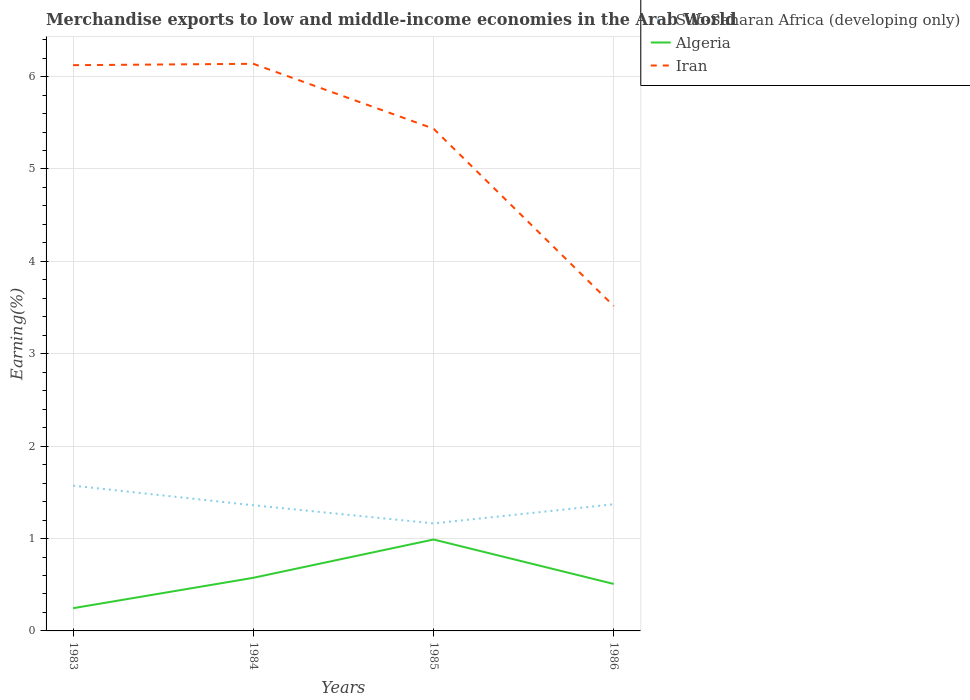Is the number of lines equal to the number of legend labels?
Ensure brevity in your answer.  Yes. Across all years, what is the maximum percentage of amount earned from merchandise exports in Sub-Saharan Africa (developing only)?
Keep it short and to the point. 1.16. What is the total percentage of amount earned from merchandise exports in Sub-Saharan Africa (developing only) in the graph?
Your answer should be very brief. 0.21. What is the difference between the highest and the second highest percentage of amount earned from merchandise exports in Algeria?
Give a very brief answer. 0.74. Is the percentage of amount earned from merchandise exports in Iran strictly greater than the percentage of amount earned from merchandise exports in Sub-Saharan Africa (developing only) over the years?
Your answer should be very brief. No. How many lines are there?
Keep it short and to the point. 3. Are the values on the major ticks of Y-axis written in scientific E-notation?
Provide a short and direct response. No. Does the graph contain grids?
Your answer should be very brief. Yes. How are the legend labels stacked?
Keep it short and to the point. Vertical. What is the title of the graph?
Your response must be concise. Merchandise exports to low and middle-income economies in the Arab World. Does "Hong Kong" appear as one of the legend labels in the graph?
Give a very brief answer. No. What is the label or title of the Y-axis?
Provide a succinct answer. Earning(%). What is the Earning(%) of Sub-Saharan Africa (developing only) in 1983?
Provide a short and direct response. 1.57. What is the Earning(%) in Algeria in 1983?
Offer a very short reply. 0.25. What is the Earning(%) in Iran in 1983?
Provide a short and direct response. 6.12. What is the Earning(%) of Sub-Saharan Africa (developing only) in 1984?
Offer a terse response. 1.36. What is the Earning(%) in Algeria in 1984?
Give a very brief answer. 0.57. What is the Earning(%) of Iran in 1984?
Ensure brevity in your answer.  6.14. What is the Earning(%) of Sub-Saharan Africa (developing only) in 1985?
Provide a short and direct response. 1.16. What is the Earning(%) of Algeria in 1985?
Make the answer very short. 0.99. What is the Earning(%) in Iran in 1985?
Your answer should be very brief. 5.44. What is the Earning(%) of Sub-Saharan Africa (developing only) in 1986?
Offer a terse response. 1.37. What is the Earning(%) in Algeria in 1986?
Provide a succinct answer. 0.51. What is the Earning(%) of Iran in 1986?
Provide a short and direct response. 3.52. Across all years, what is the maximum Earning(%) of Sub-Saharan Africa (developing only)?
Give a very brief answer. 1.57. Across all years, what is the maximum Earning(%) of Algeria?
Give a very brief answer. 0.99. Across all years, what is the maximum Earning(%) in Iran?
Ensure brevity in your answer.  6.14. Across all years, what is the minimum Earning(%) in Sub-Saharan Africa (developing only)?
Your answer should be very brief. 1.16. Across all years, what is the minimum Earning(%) of Algeria?
Make the answer very short. 0.25. Across all years, what is the minimum Earning(%) of Iran?
Offer a terse response. 3.52. What is the total Earning(%) of Sub-Saharan Africa (developing only) in the graph?
Your answer should be very brief. 5.47. What is the total Earning(%) in Algeria in the graph?
Your answer should be compact. 2.32. What is the total Earning(%) of Iran in the graph?
Your answer should be very brief. 21.22. What is the difference between the Earning(%) of Sub-Saharan Africa (developing only) in 1983 and that in 1984?
Ensure brevity in your answer.  0.21. What is the difference between the Earning(%) in Algeria in 1983 and that in 1984?
Offer a terse response. -0.33. What is the difference between the Earning(%) in Iran in 1983 and that in 1984?
Provide a succinct answer. -0.01. What is the difference between the Earning(%) in Sub-Saharan Africa (developing only) in 1983 and that in 1985?
Provide a short and direct response. 0.41. What is the difference between the Earning(%) of Algeria in 1983 and that in 1985?
Ensure brevity in your answer.  -0.74. What is the difference between the Earning(%) of Iran in 1983 and that in 1985?
Provide a succinct answer. 0.69. What is the difference between the Earning(%) in Sub-Saharan Africa (developing only) in 1983 and that in 1986?
Your response must be concise. 0.2. What is the difference between the Earning(%) of Algeria in 1983 and that in 1986?
Offer a terse response. -0.26. What is the difference between the Earning(%) in Iran in 1983 and that in 1986?
Keep it short and to the point. 2.61. What is the difference between the Earning(%) in Sub-Saharan Africa (developing only) in 1984 and that in 1985?
Ensure brevity in your answer.  0.2. What is the difference between the Earning(%) in Algeria in 1984 and that in 1985?
Provide a short and direct response. -0.41. What is the difference between the Earning(%) of Iran in 1984 and that in 1985?
Ensure brevity in your answer.  0.7. What is the difference between the Earning(%) in Sub-Saharan Africa (developing only) in 1984 and that in 1986?
Keep it short and to the point. -0.01. What is the difference between the Earning(%) in Algeria in 1984 and that in 1986?
Keep it short and to the point. 0.07. What is the difference between the Earning(%) of Iran in 1984 and that in 1986?
Provide a short and direct response. 2.62. What is the difference between the Earning(%) in Sub-Saharan Africa (developing only) in 1985 and that in 1986?
Offer a terse response. -0.21. What is the difference between the Earning(%) of Algeria in 1985 and that in 1986?
Offer a very short reply. 0.48. What is the difference between the Earning(%) in Iran in 1985 and that in 1986?
Provide a short and direct response. 1.92. What is the difference between the Earning(%) in Sub-Saharan Africa (developing only) in 1983 and the Earning(%) in Iran in 1984?
Make the answer very short. -4.57. What is the difference between the Earning(%) of Algeria in 1983 and the Earning(%) of Iran in 1984?
Offer a terse response. -5.89. What is the difference between the Earning(%) of Sub-Saharan Africa (developing only) in 1983 and the Earning(%) of Algeria in 1985?
Make the answer very short. 0.58. What is the difference between the Earning(%) in Sub-Saharan Africa (developing only) in 1983 and the Earning(%) in Iran in 1985?
Provide a succinct answer. -3.86. What is the difference between the Earning(%) of Algeria in 1983 and the Earning(%) of Iran in 1985?
Provide a short and direct response. -5.19. What is the difference between the Earning(%) of Sub-Saharan Africa (developing only) in 1983 and the Earning(%) of Algeria in 1986?
Offer a very short reply. 1.06. What is the difference between the Earning(%) of Sub-Saharan Africa (developing only) in 1983 and the Earning(%) of Iran in 1986?
Provide a short and direct response. -1.94. What is the difference between the Earning(%) of Algeria in 1983 and the Earning(%) of Iran in 1986?
Your answer should be compact. -3.27. What is the difference between the Earning(%) in Sub-Saharan Africa (developing only) in 1984 and the Earning(%) in Algeria in 1985?
Give a very brief answer. 0.37. What is the difference between the Earning(%) in Sub-Saharan Africa (developing only) in 1984 and the Earning(%) in Iran in 1985?
Offer a very short reply. -4.08. What is the difference between the Earning(%) of Algeria in 1984 and the Earning(%) of Iran in 1985?
Make the answer very short. -4.86. What is the difference between the Earning(%) in Sub-Saharan Africa (developing only) in 1984 and the Earning(%) in Algeria in 1986?
Offer a terse response. 0.85. What is the difference between the Earning(%) of Sub-Saharan Africa (developing only) in 1984 and the Earning(%) of Iran in 1986?
Your answer should be compact. -2.16. What is the difference between the Earning(%) of Algeria in 1984 and the Earning(%) of Iran in 1986?
Your response must be concise. -2.94. What is the difference between the Earning(%) of Sub-Saharan Africa (developing only) in 1985 and the Earning(%) of Algeria in 1986?
Your response must be concise. 0.66. What is the difference between the Earning(%) in Sub-Saharan Africa (developing only) in 1985 and the Earning(%) in Iran in 1986?
Give a very brief answer. -2.35. What is the difference between the Earning(%) in Algeria in 1985 and the Earning(%) in Iran in 1986?
Your response must be concise. -2.53. What is the average Earning(%) of Sub-Saharan Africa (developing only) per year?
Make the answer very short. 1.37. What is the average Earning(%) of Algeria per year?
Keep it short and to the point. 0.58. What is the average Earning(%) in Iran per year?
Make the answer very short. 5.3. In the year 1983, what is the difference between the Earning(%) of Sub-Saharan Africa (developing only) and Earning(%) of Algeria?
Provide a short and direct response. 1.33. In the year 1983, what is the difference between the Earning(%) of Sub-Saharan Africa (developing only) and Earning(%) of Iran?
Offer a very short reply. -4.55. In the year 1983, what is the difference between the Earning(%) in Algeria and Earning(%) in Iran?
Provide a succinct answer. -5.88. In the year 1984, what is the difference between the Earning(%) of Sub-Saharan Africa (developing only) and Earning(%) of Algeria?
Ensure brevity in your answer.  0.79. In the year 1984, what is the difference between the Earning(%) in Sub-Saharan Africa (developing only) and Earning(%) in Iran?
Provide a succinct answer. -4.78. In the year 1984, what is the difference between the Earning(%) in Algeria and Earning(%) in Iran?
Offer a very short reply. -5.56. In the year 1985, what is the difference between the Earning(%) in Sub-Saharan Africa (developing only) and Earning(%) in Algeria?
Offer a very short reply. 0.17. In the year 1985, what is the difference between the Earning(%) of Sub-Saharan Africa (developing only) and Earning(%) of Iran?
Your answer should be compact. -4.27. In the year 1985, what is the difference between the Earning(%) in Algeria and Earning(%) in Iran?
Provide a succinct answer. -4.45. In the year 1986, what is the difference between the Earning(%) of Sub-Saharan Africa (developing only) and Earning(%) of Algeria?
Your answer should be very brief. 0.86. In the year 1986, what is the difference between the Earning(%) in Sub-Saharan Africa (developing only) and Earning(%) in Iran?
Your answer should be compact. -2.15. In the year 1986, what is the difference between the Earning(%) in Algeria and Earning(%) in Iran?
Provide a succinct answer. -3.01. What is the ratio of the Earning(%) of Sub-Saharan Africa (developing only) in 1983 to that in 1984?
Provide a short and direct response. 1.16. What is the ratio of the Earning(%) of Algeria in 1983 to that in 1984?
Provide a succinct answer. 0.43. What is the ratio of the Earning(%) of Iran in 1983 to that in 1984?
Make the answer very short. 1. What is the ratio of the Earning(%) of Sub-Saharan Africa (developing only) in 1983 to that in 1985?
Your answer should be very brief. 1.35. What is the ratio of the Earning(%) in Algeria in 1983 to that in 1985?
Your response must be concise. 0.25. What is the ratio of the Earning(%) of Iran in 1983 to that in 1985?
Provide a short and direct response. 1.13. What is the ratio of the Earning(%) in Sub-Saharan Africa (developing only) in 1983 to that in 1986?
Offer a terse response. 1.15. What is the ratio of the Earning(%) of Algeria in 1983 to that in 1986?
Your response must be concise. 0.48. What is the ratio of the Earning(%) of Iran in 1983 to that in 1986?
Your answer should be compact. 1.74. What is the ratio of the Earning(%) of Sub-Saharan Africa (developing only) in 1984 to that in 1985?
Your response must be concise. 1.17. What is the ratio of the Earning(%) of Algeria in 1984 to that in 1985?
Your response must be concise. 0.58. What is the ratio of the Earning(%) in Iran in 1984 to that in 1985?
Ensure brevity in your answer.  1.13. What is the ratio of the Earning(%) in Algeria in 1984 to that in 1986?
Offer a terse response. 1.13. What is the ratio of the Earning(%) of Iran in 1984 to that in 1986?
Make the answer very short. 1.75. What is the ratio of the Earning(%) of Sub-Saharan Africa (developing only) in 1985 to that in 1986?
Your answer should be very brief. 0.85. What is the ratio of the Earning(%) in Algeria in 1985 to that in 1986?
Provide a succinct answer. 1.95. What is the ratio of the Earning(%) of Iran in 1985 to that in 1986?
Offer a terse response. 1.55. What is the difference between the highest and the second highest Earning(%) in Sub-Saharan Africa (developing only)?
Offer a terse response. 0.2. What is the difference between the highest and the second highest Earning(%) in Algeria?
Provide a short and direct response. 0.41. What is the difference between the highest and the second highest Earning(%) in Iran?
Offer a terse response. 0.01. What is the difference between the highest and the lowest Earning(%) in Sub-Saharan Africa (developing only)?
Make the answer very short. 0.41. What is the difference between the highest and the lowest Earning(%) of Algeria?
Your response must be concise. 0.74. What is the difference between the highest and the lowest Earning(%) in Iran?
Ensure brevity in your answer.  2.62. 